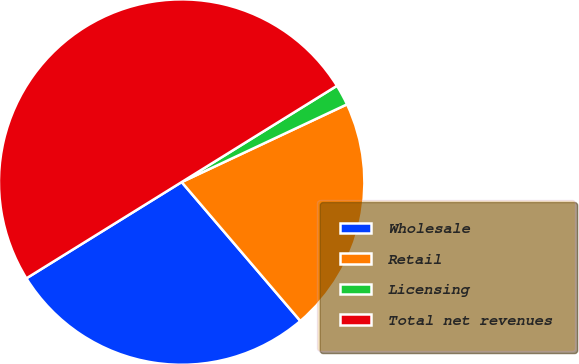<chart> <loc_0><loc_0><loc_500><loc_500><pie_chart><fcel>Wholesale<fcel>Retail<fcel>Licensing<fcel>Total net revenues<nl><fcel>27.42%<fcel>20.74%<fcel>1.84%<fcel>50.0%<nl></chart> 